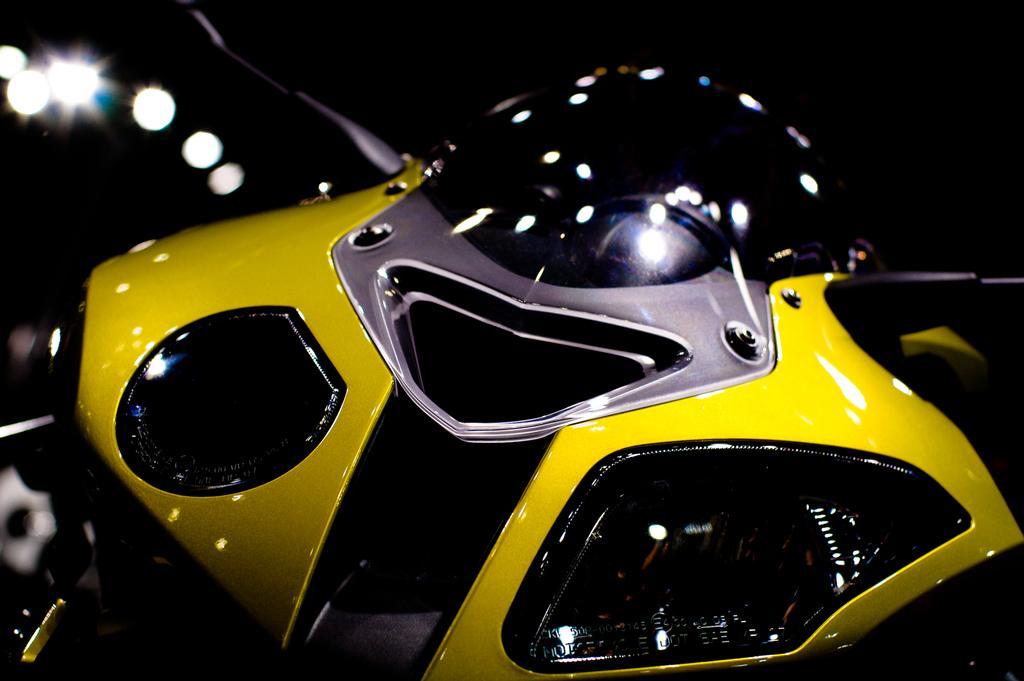Describe this image in one or two sentences. In this picture I can see a motorbike and I can see few lights. 